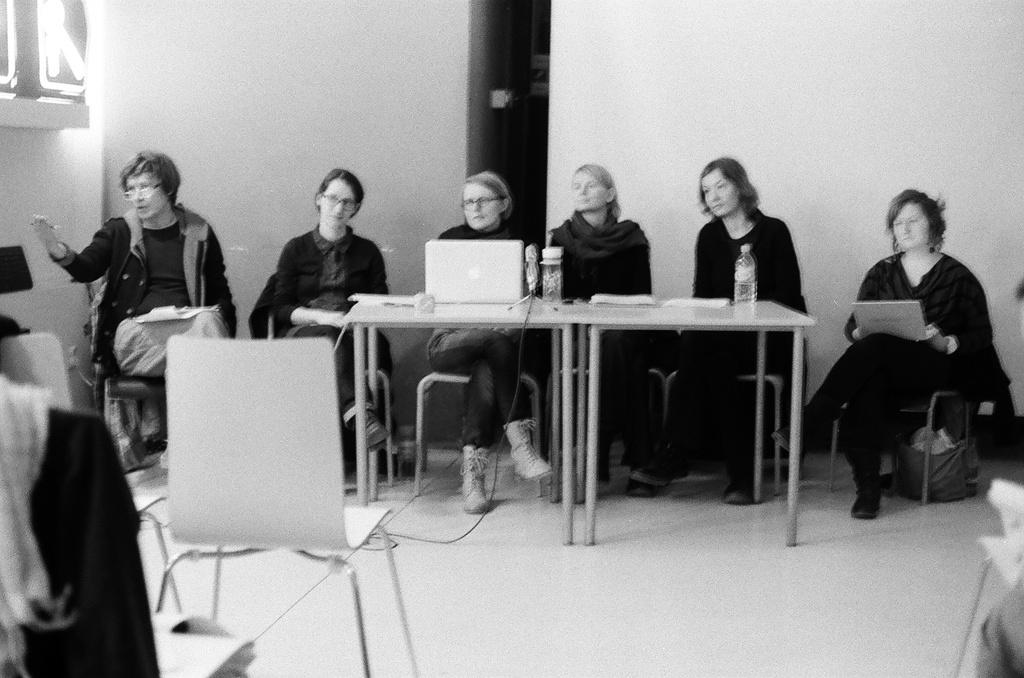How many women are present in the image? There are six women in the image. What are the women doing in the image? The women are sitting in chairs. Where are the chairs located? The chairs are around a table. What objects can be seen on the table? There are laptops, water bottles, and papers on the table. What is visible in the background of the image? There is a wall visible in the image. What type of juice is being served to the cattle in the image? There are no cattle or juice present in the image. How does the image look from the perspective of the women? The question is not relevant to the image, as it asks about the perspective of the women rather than the objects or subjects present in the image. 